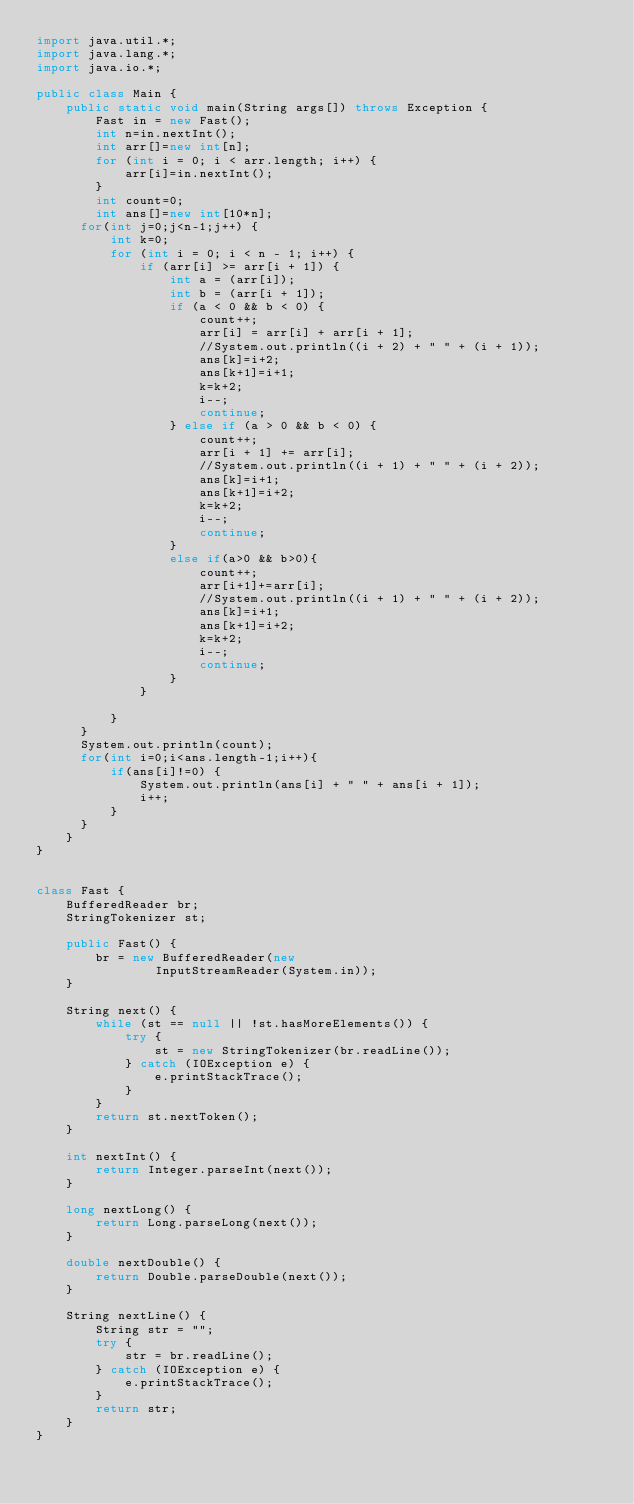<code> <loc_0><loc_0><loc_500><loc_500><_Java_>import java.util.*;
import java.lang.*;
import java.io.*;

public class Main {
    public static void main(String args[]) throws Exception {
        Fast in = new Fast();
        int n=in.nextInt();
        int arr[]=new int[n];
        for (int i = 0; i < arr.length; i++) {
            arr[i]=in.nextInt();
        }
        int count=0;
        int ans[]=new int[10*n];
      for(int j=0;j<n-1;j++) {
          int k=0;
          for (int i = 0; i < n - 1; i++) {
              if (arr[i] >= arr[i + 1]) {
                  int a = (arr[i]);
                  int b = (arr[i + 1]);
                  if (a < 0 && b < 0) {
                      count++;
                      arr[i] = arr[i] + arr[i + 1];
                      //System.out.println((i + 2) + " " + (i + 1));
                      ans[k]=i+2;
                      ans[k+1]=i+1;
                      k=k+2;
                      i--;
                      continue;
                  } else if (a > 0 && b < 0) {
                      count++;
                      arr[i + 1] += arr[i];
                      //System.out.println((i + 1) + " " + (i + 2));
                      ans[k]=i+1;
                      ans[k+1]=i+2;
                      k=k+2;
                      i--;
                      continue;
                  }
                  else if(a>0 && b>0){
                      count++;
                      arr[i+1]+=arr[i];
                      //System.out.println((i + 1) + " " + (i + 2));
                      ans[k]=i+1;
                      ans[k+1]=i+2;
                      k=k+2;
                      i--;
                      continue;
                  }
              }

          }
      }
      System.out.println(count);
      for(int i=0;i<ans.length-1;i++){
          if(ans[i]!=0) {
              System.out.println(ans[i] + " " + ans[i + 1]);
              i++;
          }
      }
    }
}


class Fast {
    BufferedReader br;
    StringTokenizer st;

    public Fast() {
        br = new BufferedReader(new
                InputStreamReader(System.in));
    }

    String next() {
        while (st == null || !st.hasMoreElements()) {
            try {
                st = new StringTokenizer(br.readLine());
            } catch (IOException e) {
                e.printStackTrace();
            }
        }
        return st.nextToken();
    }

    int nextInt() {
        return Integer.parseInt(next());
    }

    long nextLong() {
        return Long.parseLong(next());
    }

    double nextDouble() {
        return Double.parseDouble(next());
    }

    String nextLine() {
        String str = "";
        try {
            str = br.readLine();
        } catch (IOException e) {
            e.printStackTrace();
        }
        return str;
    }
}

</code> 